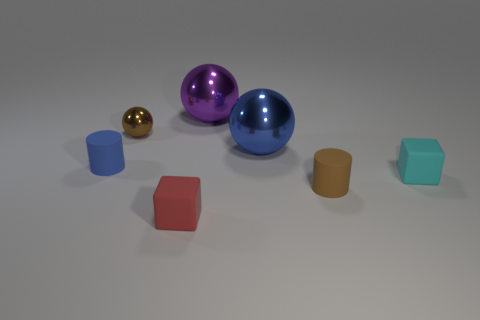Are there any big blue objects that have the same material as the blue sphere?
Your answer should be compact. No. How many metallic objects are tiny blocks or gray cylinders?
Your answer should be compact. 0. There is a big metallic thing that is in front of the small brown thing that is left of the red matte object; what shape is it?
Ensure brevity in your answer.  Sphere. Is the number of red things behind the small brown cylinder less than the number of purple matte spheres?
Your answer should be compact. No. The small metal thing has what shape?
Your answer should be compact. Sphere. What size is the shiny sphere in front of the brown metal ball?
Offer a very short reply. Large. What color is the shiny ball that is the same size as the brown matte cylinder?
Offer a terse response. Brown. Is there a metallic thing that has the same color as the small metal sphere?
Provide a succinct answer. No. Are there fewer tiny rubber objects behind the tiny brown ball than blue metallic things behind the brown rubber thing?
Make the answer very short. Yes. What is the small thing that is both behind the cyan matte cube and in front of the brown metal thing made of?
Your response must be concise. Rubber. 